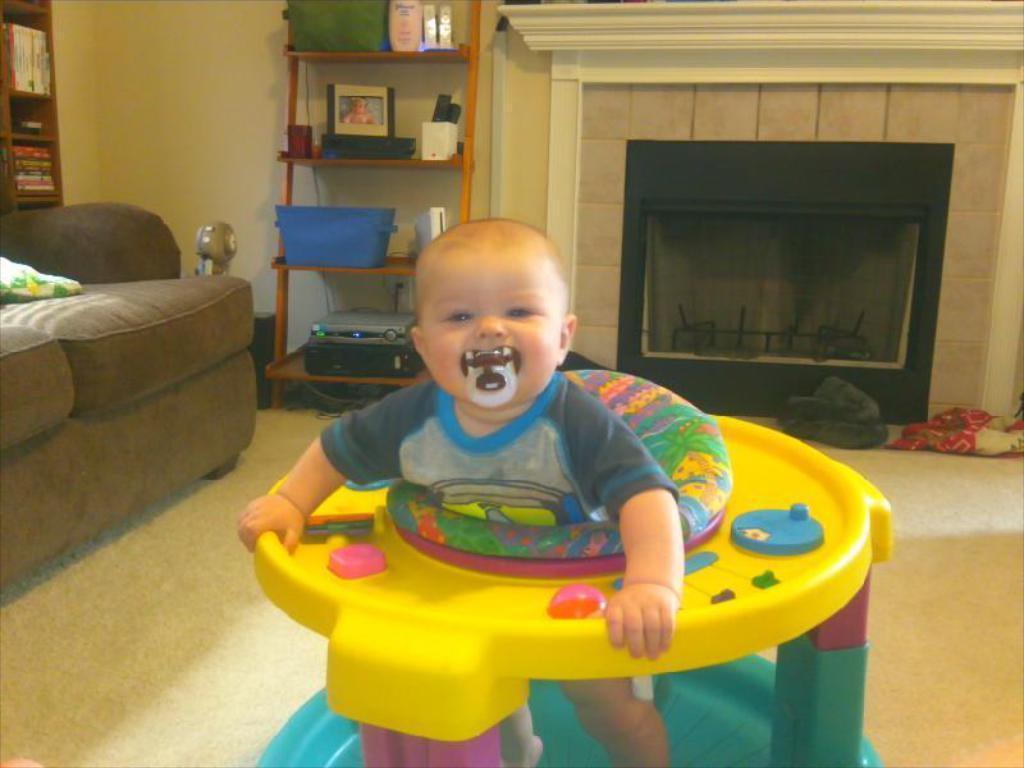Could you give a brief overview of what you see in this image? In this image a kid is sitting on the chair. Left side there is a sofa having a cushion on it. Behind the sofa there is a rack having few books in it. Beside the sofa there is a rack having a basket, picture frame, bottles, devices and few objects in it. Right side few objects are on the floor. Background there is a wall. 